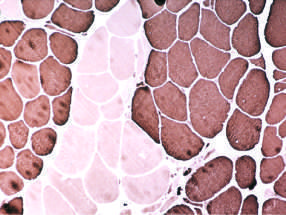do remission of demyelinating disease appear that share the same fiber type (fiber type grouping)?
Answer the question using a single word or phrase. No 